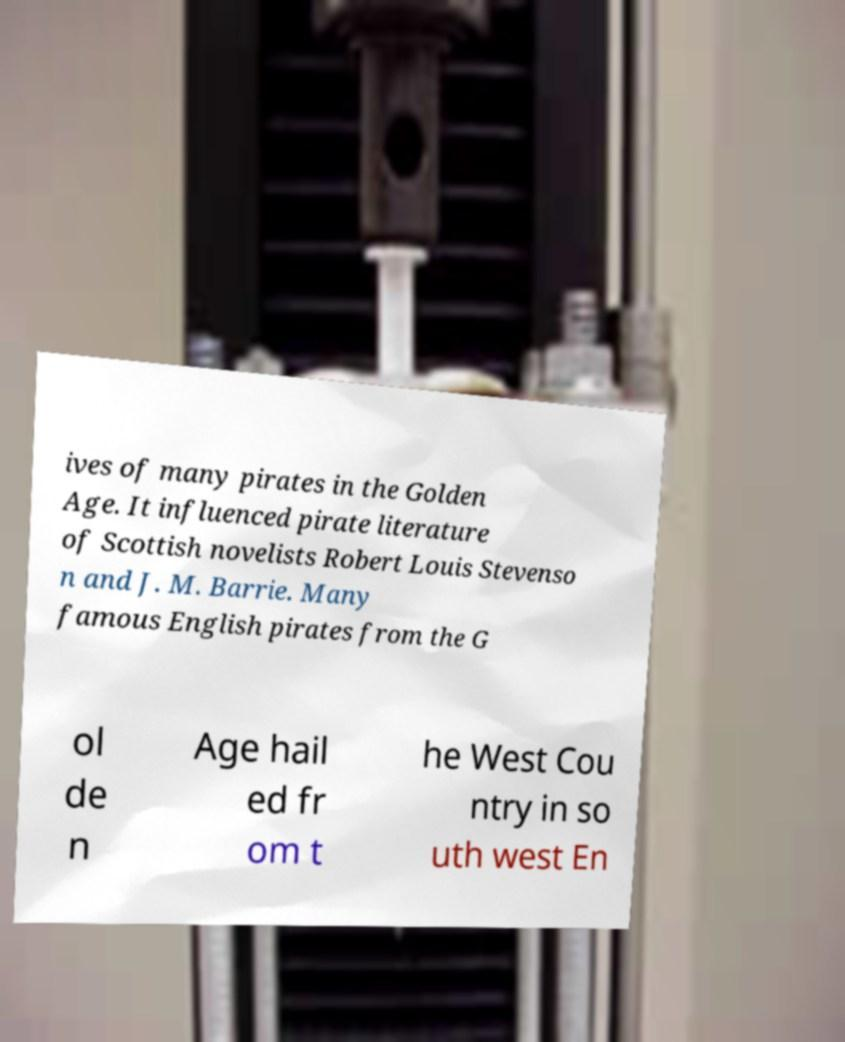There's text embedded in this image that I need extracted. Can you transcribe it verbatim? ives of many pirates in the Golden Age. It influenced pirate literature of Scottish novelists Robert Louis Stevenso n and J. M. Barrie. Many famous English pirates from the G ol de n Age hail ed fr om t he West Cou ntry in so uth west En 